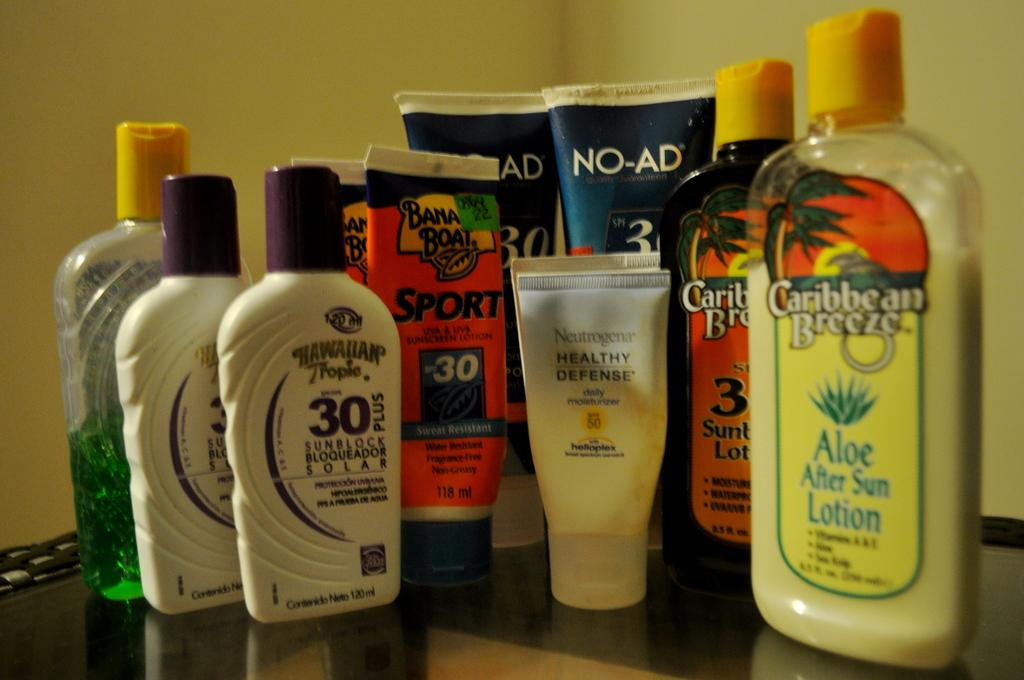<image>
Give a short and clear explanation of the subsequent image. A group of suntan lotions from Banana Boat and Caribbean Breeze. 